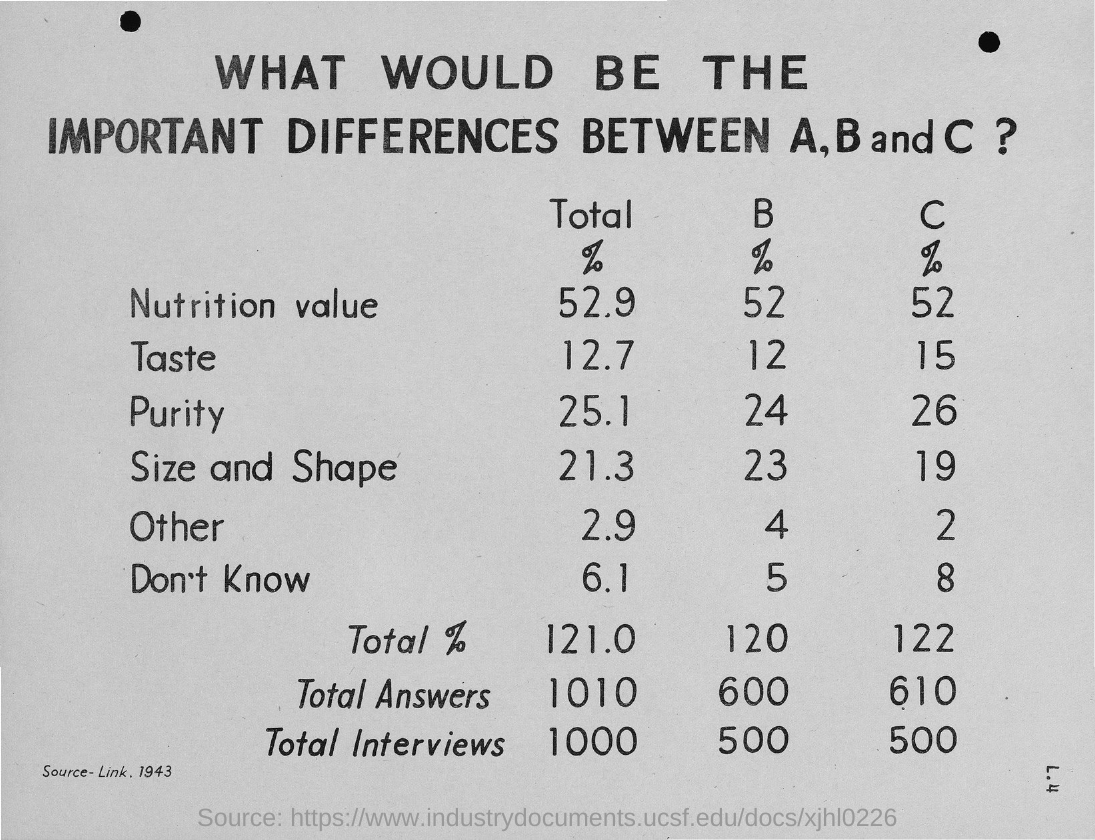Outline some significant characteristics in this image. The percentage value of purity for B is 24%. 